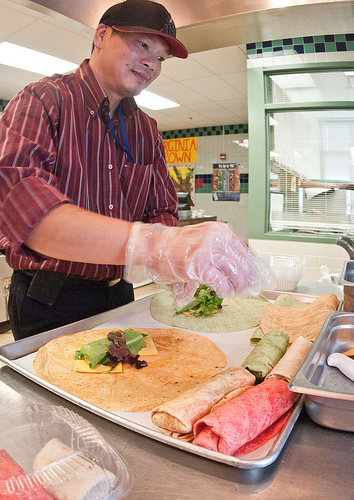<image>
Is the man on the burrito? No. The man is not positioned on the burrito. They may be near each other, but the man is not supported by or resting on top of the burrito. 